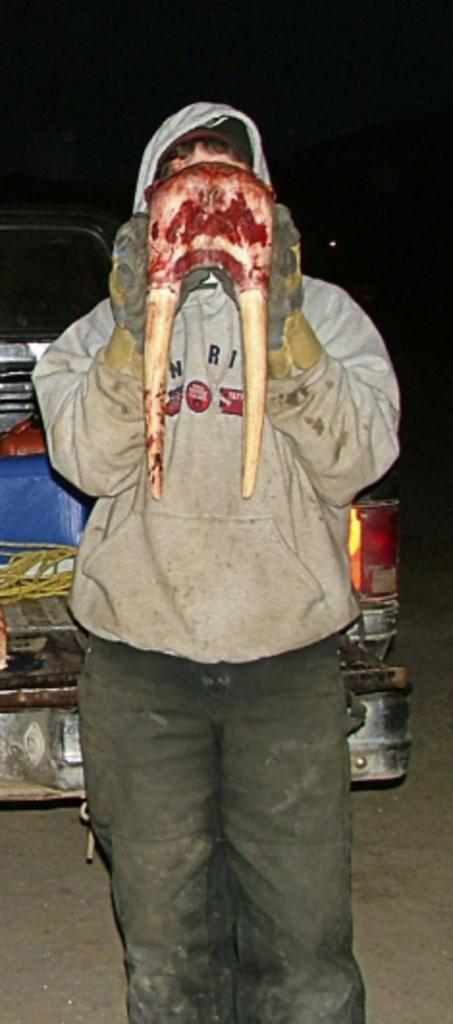Who is present in the image? There is a man in the image. What is the man holding in his hand? The man is holding something in his hand. What can be seen behind the man in the image? There is a vehicle visible behind the man. What is the reaction of the man to the expansion of time in the image? There is no mention of time or any expansion in the image, so it is not possible to determine the man's reaction to it. 